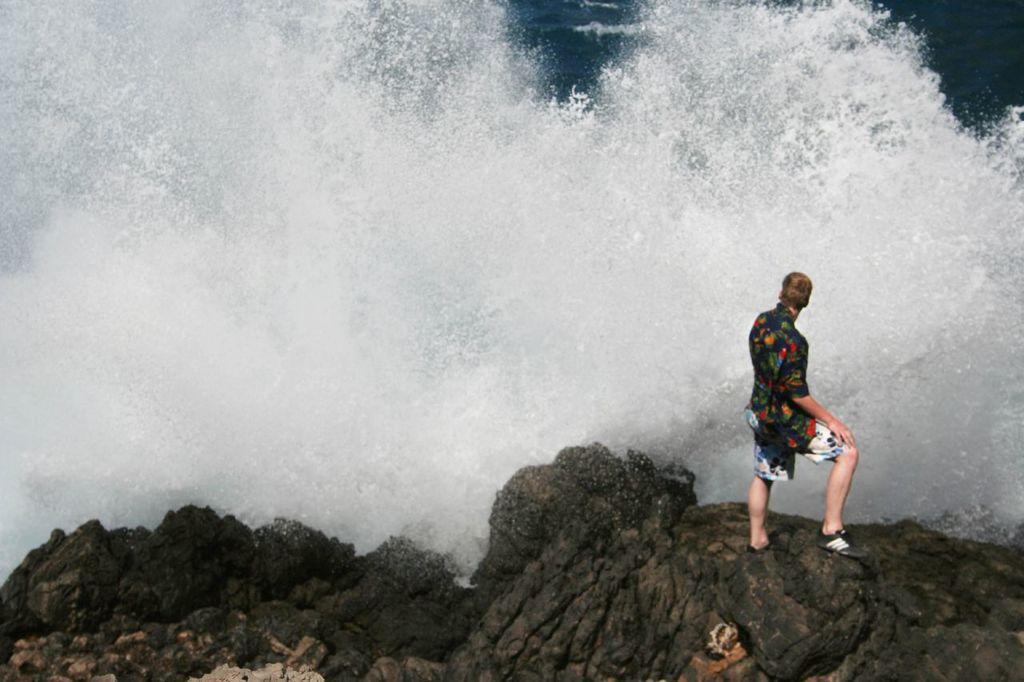Could you give a brief overview of what you see in this image? In this picture we can see a person is standing, there are rocks at the bottom, we can see water in the background. 